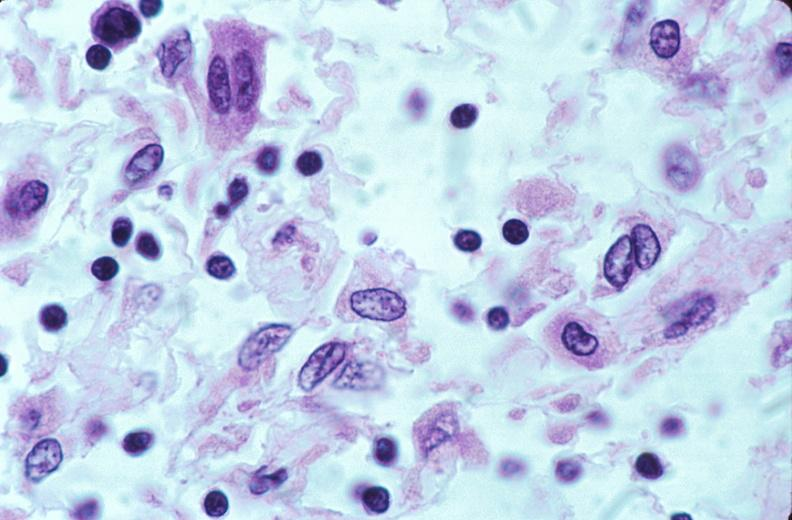does intestine show lymph nodes, nodular sclerosing hodgkins disease?
Answer the question using a single word or phrase. No 